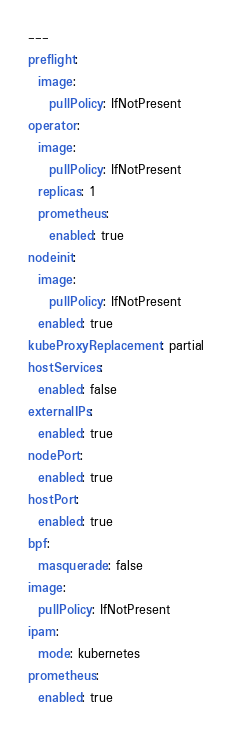<code> <loc_0><loc_0><loc_500><loc_500><_YAML_>---
preflight:
  image:
    pullPolicy: IfNotPresent
operator:
  image:
    pullPolicy: IfNotPresent
  replicas: 1
  prometheus:
    enabled: true
nodeinit:
  image:
    pullPolicy: IfNotPresent
  enabled: true
kubeProxyReplacement: partial
hostServices:
  enabled: false
externalIPs:
  enabled: true
nodePort:
  enabled: true
hostPort:
  enabled: true
bpf:
  masquerade: false
image:
  pullPolicy: IfNotPresent
ipam:
  mode: kubernetes
prometheus:
  enabled: true

</code> 